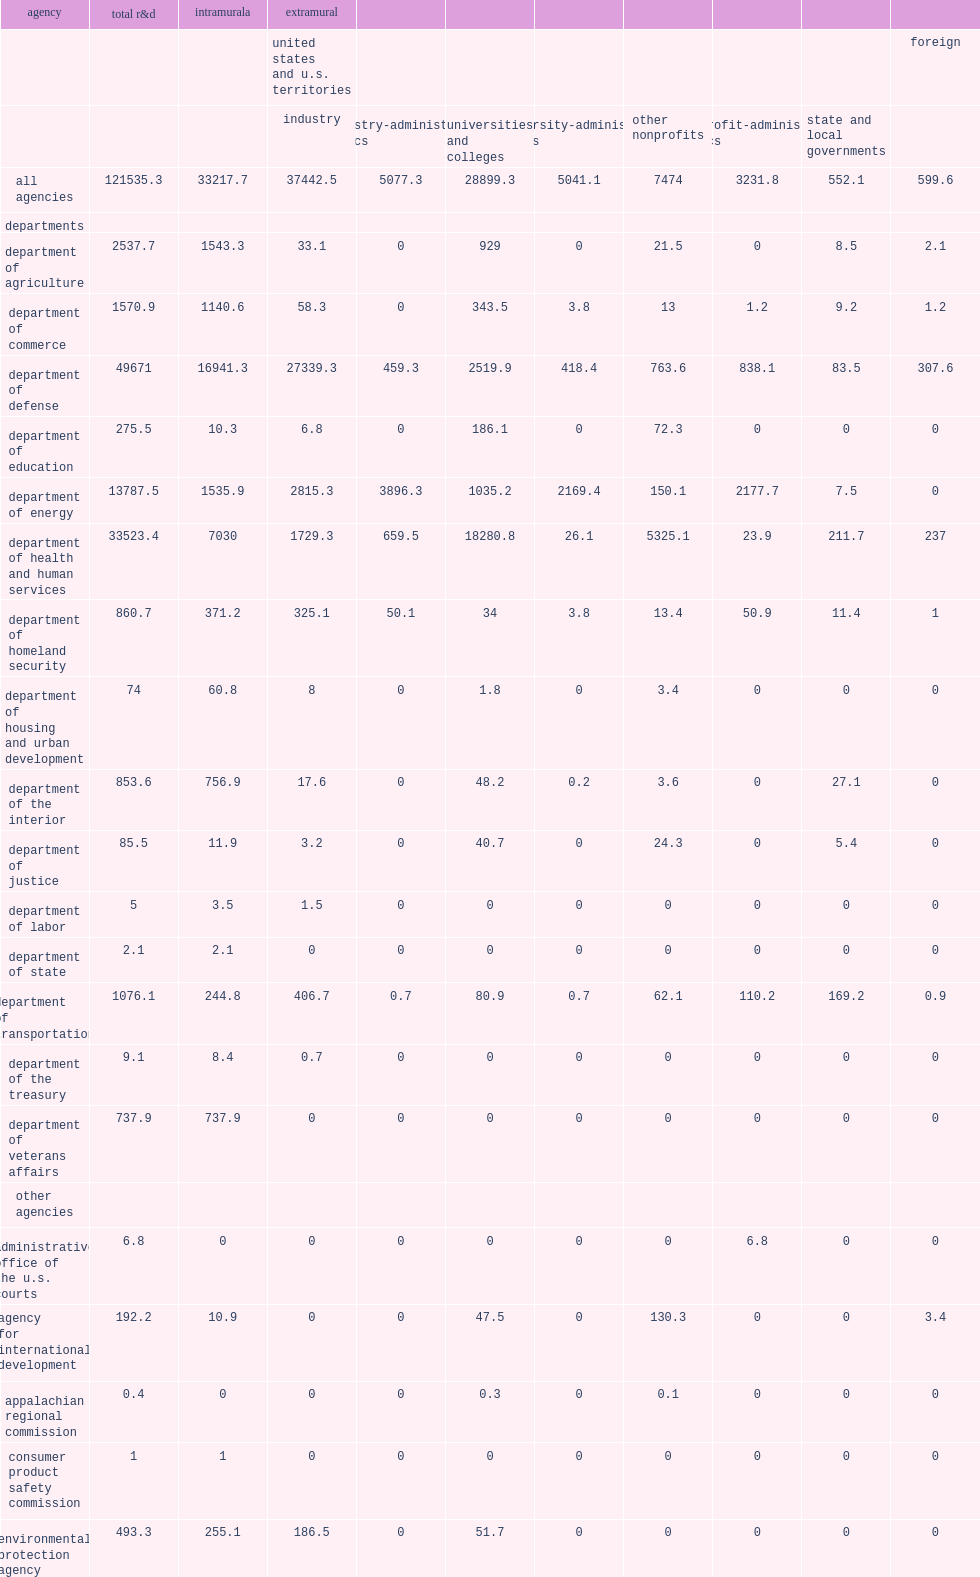How many million dollars were in federal r&d obligations in fy 2018? 121535.3. How many percent do dod account of all federal r&d obligations to industrial performers? 0.730168. 